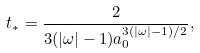Convert formula to latex. <formula><loc_0><loc_0><loc_500><loc_500>t _ { * } = \frac { 2 } { 3 ( | \omega | - 1 ) a _ { 0 } ^ { 3 ( | \omega | - 1 ) / 2 } } ,</formula> 